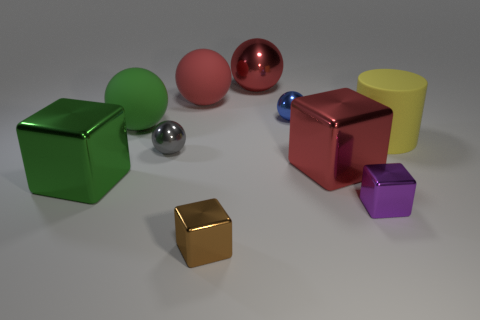Subtract all red spheres. How many were subtracted if there are1red spheres left? 1 Subtract all tiny brown cubes. How many cubes are left? 3 Subtract all gray cubes. How many red spheres are left? 2 Subtract all blue balls. How many balls are left? 4 Subtract all cubes. How many objects are left? 6 Subtract all brown cubes. Subtract all yellow spheres. How many cubes are left? 3 Subtract all brown matte blocks. Subtract all large yellow matte things. How many objects are left? 9 Add 9 purple metallic blocks. How many purple metallic blocks are left? 10 Add 4 brown things. How many brown things exist? 5 Subtract 0 purple spheres. How many objects are left? 10 